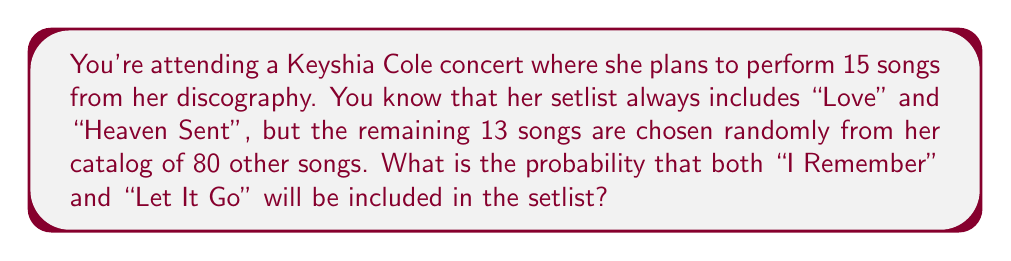What is the answer to this math problem? Let's approach this step-by-step:

1) We know that 2 songs are fixed ("Love" and "Heaven Sent"), so we're really concerned with the probability of selecting both "I Remember" and "Let It Go" from the remaining 13 slots.

2) This is a combination problem. We need to calculate the probability of selecting both these songs out of the 80 possible songs.

3) We can use the hypergeometric distribution for this calculation. The probability is:

   $$P(\text{both songs}) = \frac{\binom{2}{2}\binom{78}{11}}{\binom{80}{13}}$$

   Where:
   - $\binom{2}{2}$ represents selecting both of our desired songs
   - $\binom{78}{11}$ represents selecting the other 11 songs from the remaining 78 songs
   - $\binom{80}{13}$ represents all possible ways to select 13 songs from 80 songs

4) Let's calculate each part:
   
   $\binom{2}{2} = 1$
   
   $\binom{78}{11} = 1,341,426,838,509,300$
   
   $\binom{80}{13} = 3,535,316,142,212,174,320$

5) Now, let's substitute these values:

   $$P(\text{both songs}) = \frac{1 \times 1,341,426,838,509,300}{3,535,316,142,212,174,320}$$

6) Simplifying:

   $$P(\text{both songs}) = 0.3794 \approx 0.3794$$
Answer: The probability that both "I Remember" and "Let It Go" will be included in the setlist is approximately 0.3794 or 37.94%. 